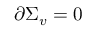Convert formula to latex. <formula><loc_0><loc_0><loc_500><loc_500>\partial \Sigma _ { v } = 0</formula> 